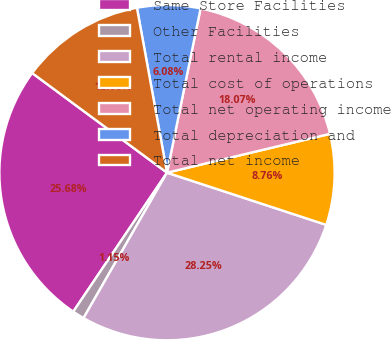Convert chart. <chart><loc_0><loc_0><loc_500><loc_500><pie_chart><fcel>Same Store Facilities<fcel>Other Facilities<fcel>Total rental income<fcel>Total cost of operations<fcel>Total net operating income<fcel>Total depreciation and<fcel>Total net income<nl><fcel>25.68%<fcel>1.15%<fcel>28.25%<fcel>8.76%<fcel>18.07%<fcel>6.08%<fcel>12.0%<nl></chart> 